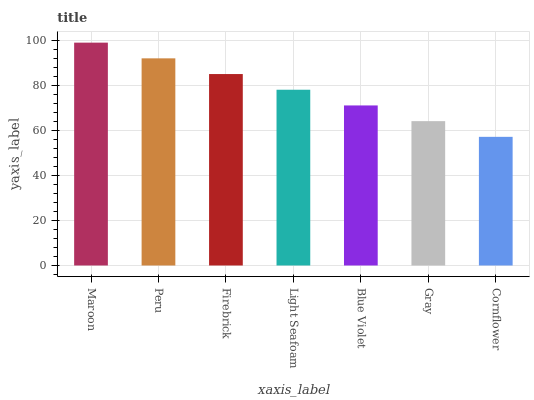Is Cornflower the minimum?
Answer yes or no. Yes. Is Maroon the maximum?
Answer yes or no. Yes. Is Peru the minimum?
Answer yes or no. No. Is Peru the maximum?
Answer yes or no. No. Is Maroon greater than Peru?
Answer yes or no. Yes. Is Peru less than Maroon?
Answer yes or no. Yes. Is Peru greater than Maroon?
Answer yes or no. No. Is Maroon less than Peru?
Answer yes or no. No. Is Light Seafoam the high median?
Answer yes or no. Yes. Is Light Seafoam the low median?
Answer yes or no. Yes. Is Gray the high median?
Answer yes or no. No. Is Blue Violet the low median?
Answer yes or no. No. 